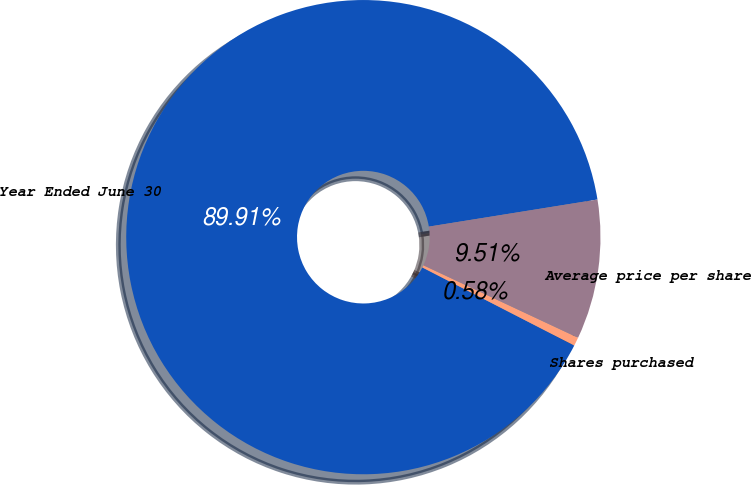Convert chart. <chart><loc_0><loc_0><loc_500><loc_500><pie_chart><fcel>Year Ended June 30<fcel>Shares purchased<fcel>Average price per share<nl><fcel>89.91%<fcel>0.58%<fcel>9.51%<nl></chart> 